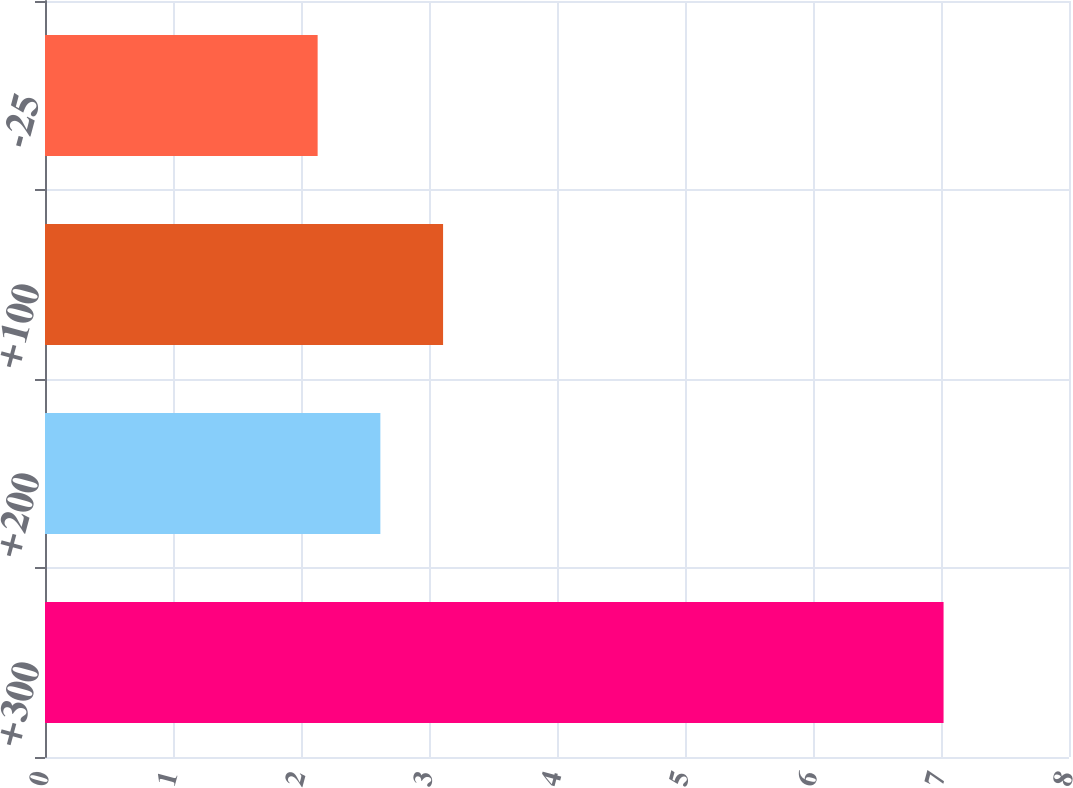<chart> <loc_0><loc_0><loc_500><loc_500><bar_chart><fcel>+300<fcel>+200<fcel>+100<fcel>-25<nl><fcel>7.02<fcel>2.62<fcel>3.11<fcel>2.13<nl></chart> 